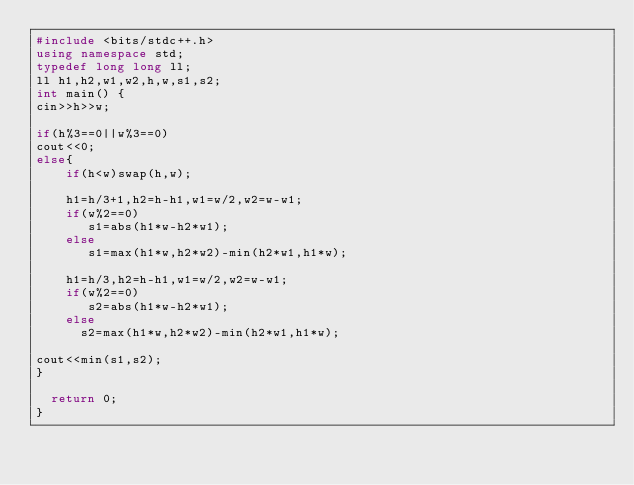<code> <loc_0><loc_0><loc_500><loc_500><_C++_>#include <bits/stdc++.h>
using namespace std;
typedef long long ll;
ll h1,h2,w1,w2,h,w,s1,s2;
int main() {
cin>>h>>w;

if(h%3==0||w%3==0)
cout<<0;
else{
	if(h<w)swap(h,w);
	
	h1=h/3+1,h2=h-h1,w1=w/2,w2=w-w1;
	if(w%2==0)
	   s1=abs(h1*w-h2*w1);
	else
	   s1=max(h1*w,h2*w2)-min(h2*w1,h1*w);
	   
	h1=h/3,h2=h-h1,w1=w/2,w2=w-w1;
	if(w%2==0)
	   s2=abs(h1*w-h2*w1);
	else
	  s2=max(h1*w,h2*w2)-min(h2*w1,h1*w);
	
cout<<min(s1,s2);	
}

  return 0;
}
</code> 